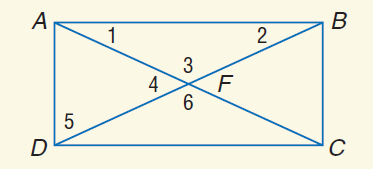Answer the mathemtical geometry problem and directly provide the correct option letter.
Question: If m \angle 2 = 70 - 4 x and m \angle 5 = 18 x - 8, find m \angle 5.
Choices: A: 2 B: 28 C: 62 D: 72 B 